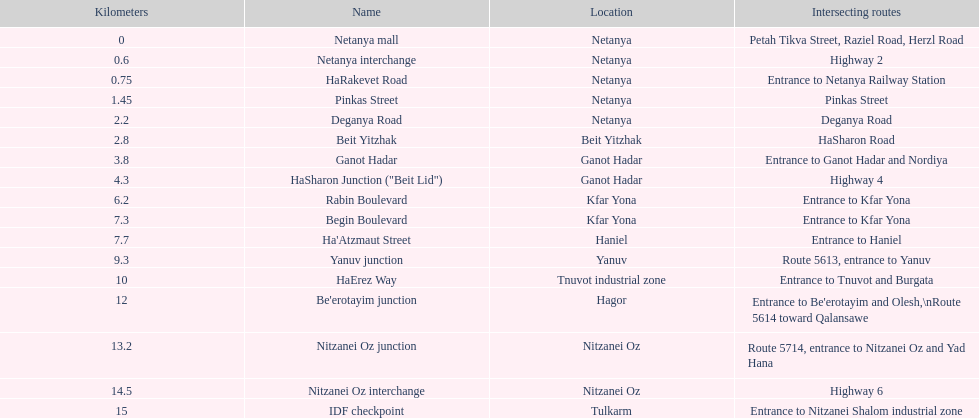What is the number of areas present in netanya? 5. 